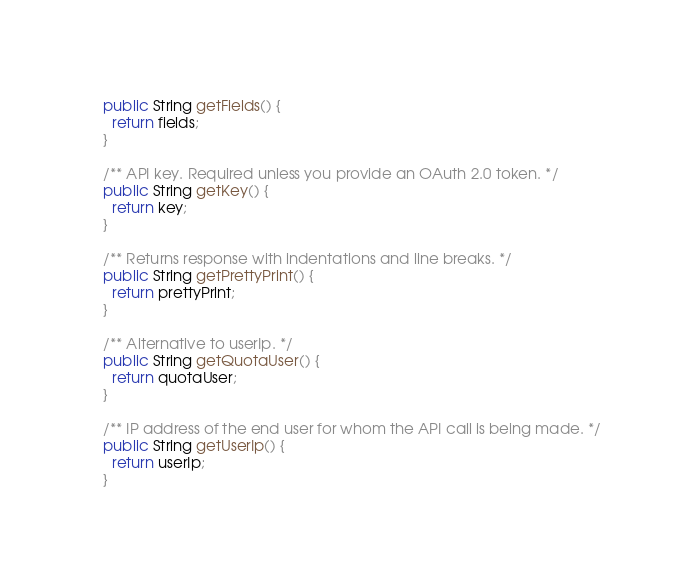<code> <loc_0><loc_0><loc_500><loc_500><_Java_>  public String getFields() {
    return fields;
  }

  /** API key. Required unless you provide an OAuth 2.0 token. */
  public String getKey() {
    return key;
  }

  /** Returns response with indentations and line breaks. */
  public String getPrettyPrint() {
    return prettyPrint;
  }

  /** Alternative to userIp. */
  public String getQuotaUser() {
    return quotaUser;
  }

  /** IP address of the end user for whom the API call is being made. */
  public String getUserIp() {
    return userIp;
  }
</code> 